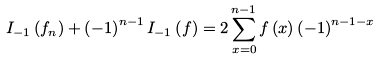<formula> <loc_0><loc_0><loc_500><loc_500>I _ { - 1 } \left ( f _ { n } \right ) + \left ( - 1 \right ) ^ { n - 1 } I _ { - 1 } \left ( f \right ) = 2 \sum _ { x = 0 } ^ { n - 1 } f \left ( x \right ) \left ( - 1 \right ) ^ { n - 1 - x }</formula> 